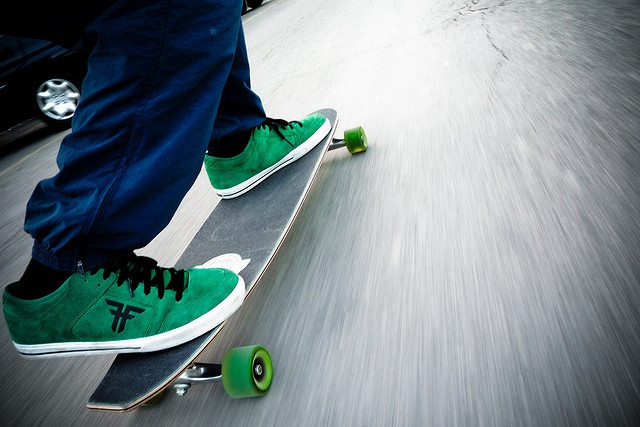Describe the objects in this image and their specific colors. I can see people in black, navy, teal, and white tones, skateboard in black and gray tones, and car in black, white, gray, and blue tones in this image. 